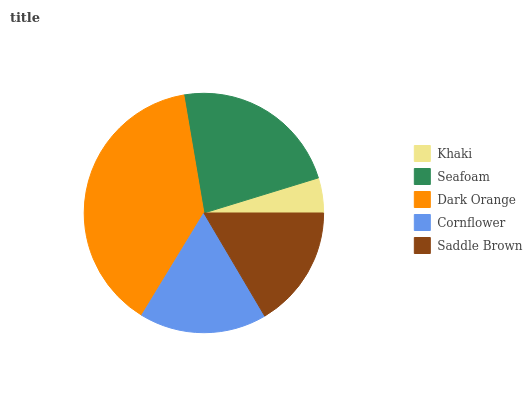Is Khaki the minimum?
Answer yes or no. Yes. Is Dark Orange the maximum?
Answer yes or no. Yes. Is Seafoam the minimum?
Answer yes or no. No. Is Seafoam the maximum?
Answer yes or no. No. Is Seafoam greater than Khaki?
Answer yes or no. Yes. Is Khaki less than Seafoam?
Answer yes or no. Yes. Is Khaki greater than Seafoam?
Answer yes or no. No. Is Seafoam less than Khaki?
Answer yes or no. No. Is Cornflower the high median?
Answer yes or no. Yes. Is Cornflower the low median?
Answer yes or no. Yes. Is Saddle Brown the high median?
Answer yes or no. No. Is Dark Orange the low median?
Answer yes or no. No. 